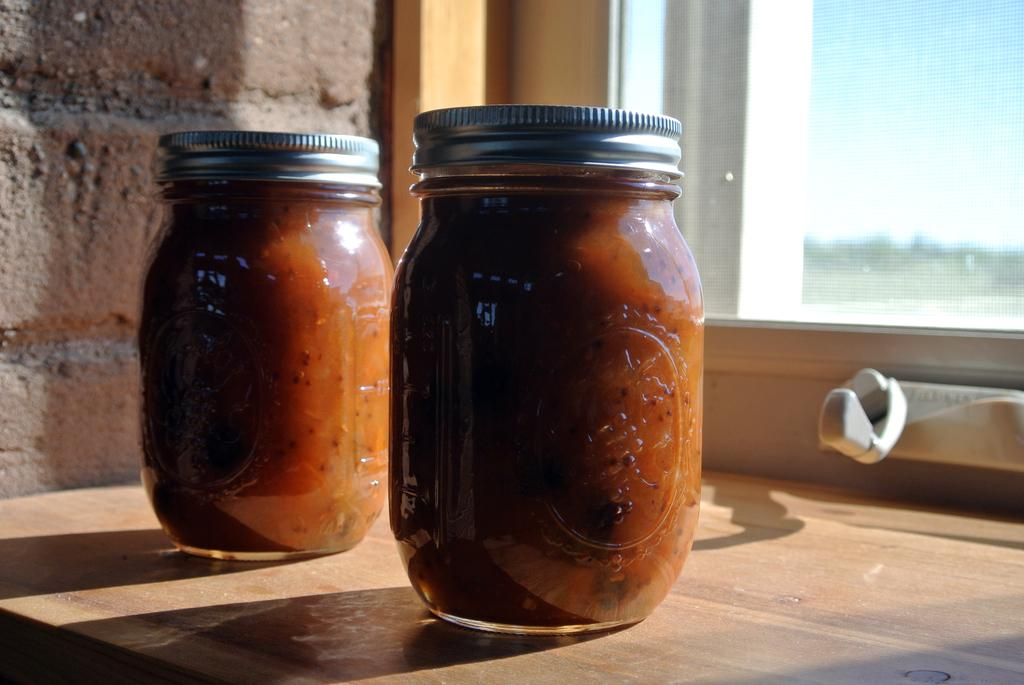What objects are placed on the table in the image? There are jars placed on the table in the image. What can be seen in the background of the image? There is a wall and a window in the background of the image. What type of wine is being served by the doctor in the image? There is no doctor or wine present in the image; it only features jars on a table with a wall and window in the background. 